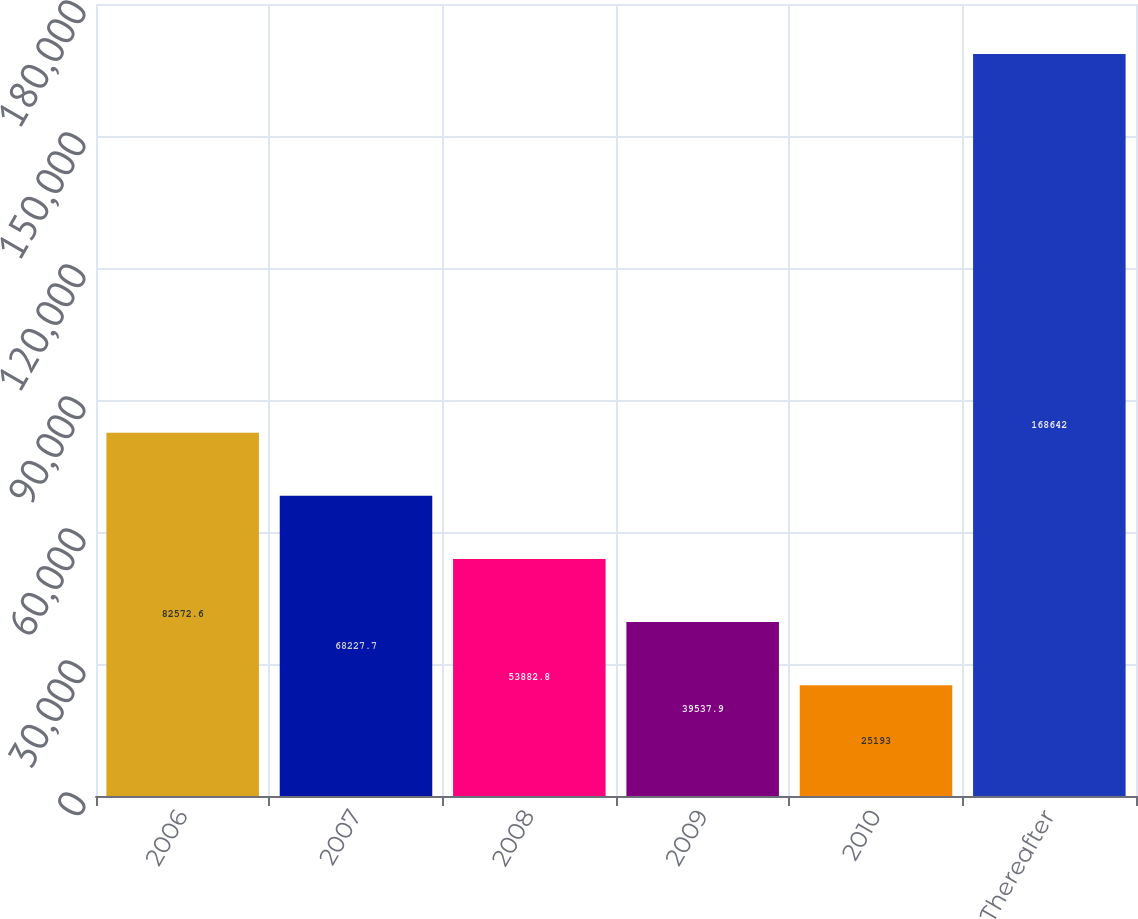<chart> <loc_0><loc_0><loc_500><loc_500><bar_chart><fcel>2006<fcel>2007<fcel>2008<fcel>2009<fcel>2010<fcel>Thereafter<nl><fcel>82572.6<fcel>68227.7<fcel>53882.8<fcel>39537.9<fcel>25193<fcel>168642<nl></chart> 